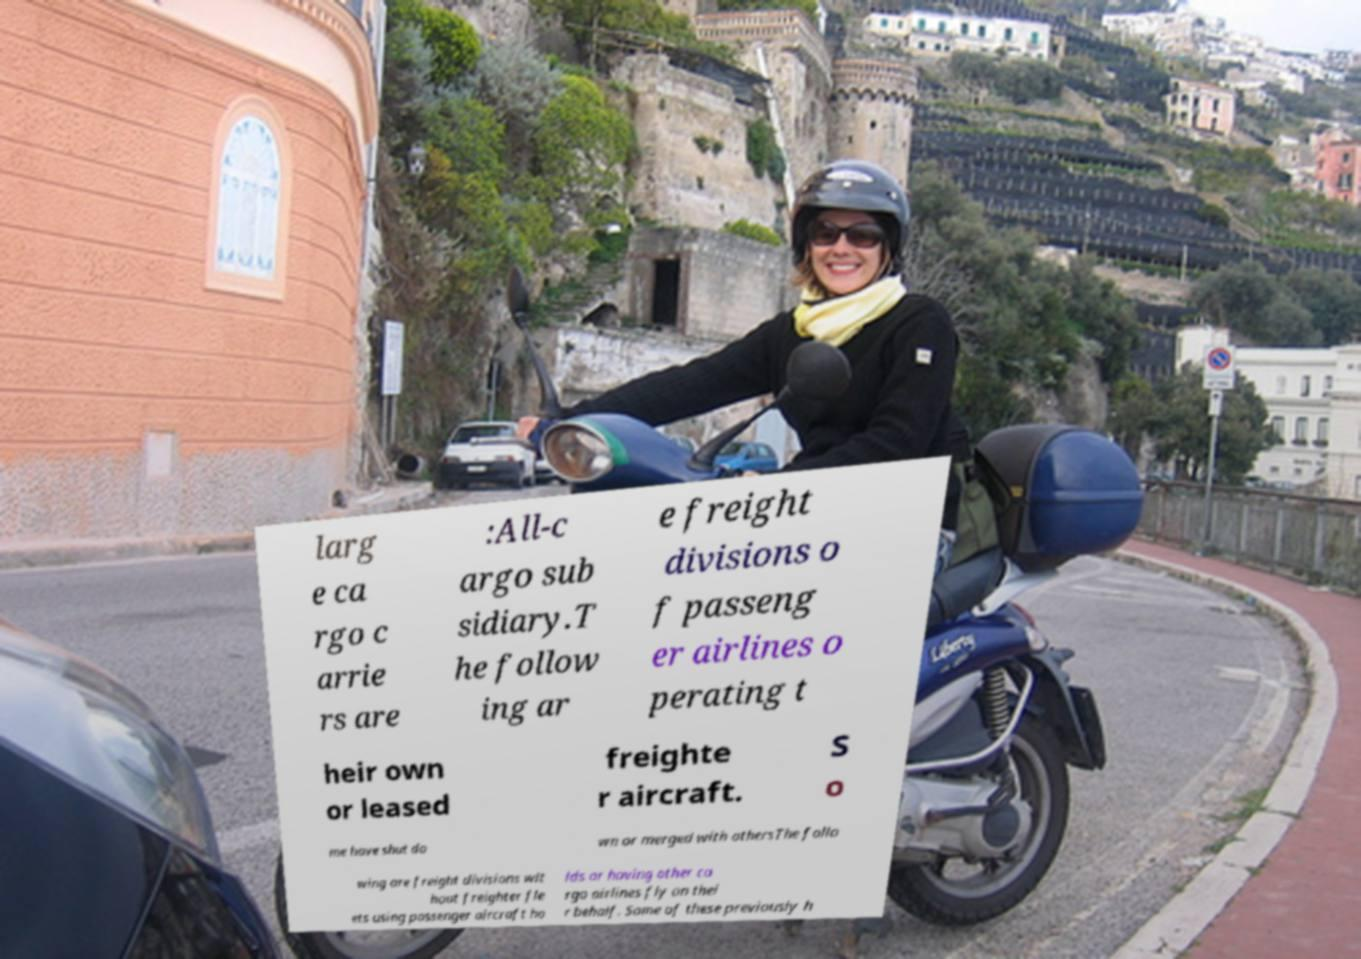What messages or text are displayed in this image? I need them in a readable, typed format. larg e ca rgo c arrie rs are :All-c argo sub sidiary.T he follow ing ar e freight divisions o f passeng er airlines o perating t heir own or leased freighte r aircraft. S o me have shut do wn or merged with othersThe follo wing are freight divisions wit hout freighter fle ets using passenger aircraft ho lds or having other ca rgo airlines fly on thei r behalf. Some of these previously h 